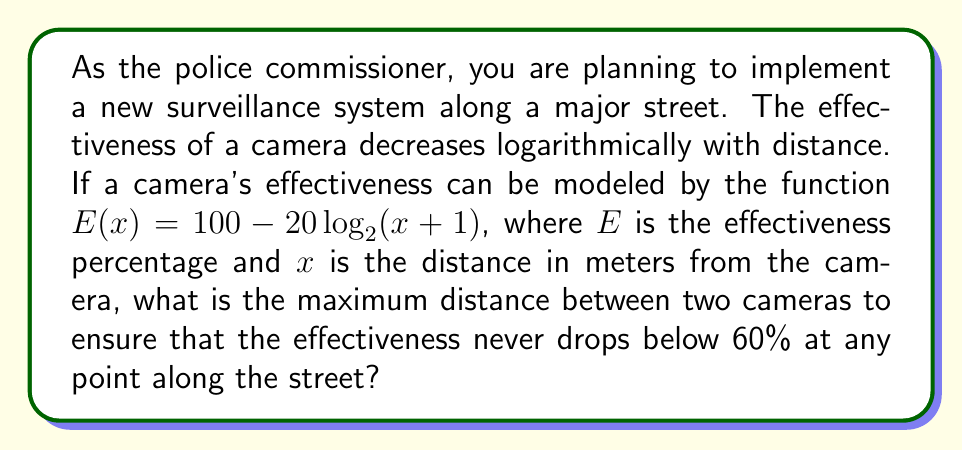Solve this math problem. To solve this problem, we need to follow these steps:

1) We want to find the distance at which the effectiveness drops to 60%. Let's set up the equation:

   $60 = 100 - 20\log_2(x+1)$

2) Subtract both sides from 100:

   $40 = 20\log_2(x+1)$

3) Divide both sides by 20:

   $2 = \log_2(x+1)$

4) Now, we need to solve for x. We can do this by applying $2^x$ to both sides:

   $2^2 = 2^{\log_2(x+1)}$

5) Simplify the left side:

   $4 = x+1$

6) Subtract 1 from both sides:

   $3 = x$

7) This means that at a distance of 3 meters from a camera, the effectiveness drops to 60%.

8) To ensure that the effectiveness never drops below 60%, we need to place cameras at twice this distance apart. This is because the midpoint between two cameras will be the point of lowest effectiveness.

   Maximum distance between cameras = $2 * 3 = 6$ meters
Answer: The maximum distance between two cameras to ensure that the effectiveness never drops below 60% is 6 meters. 